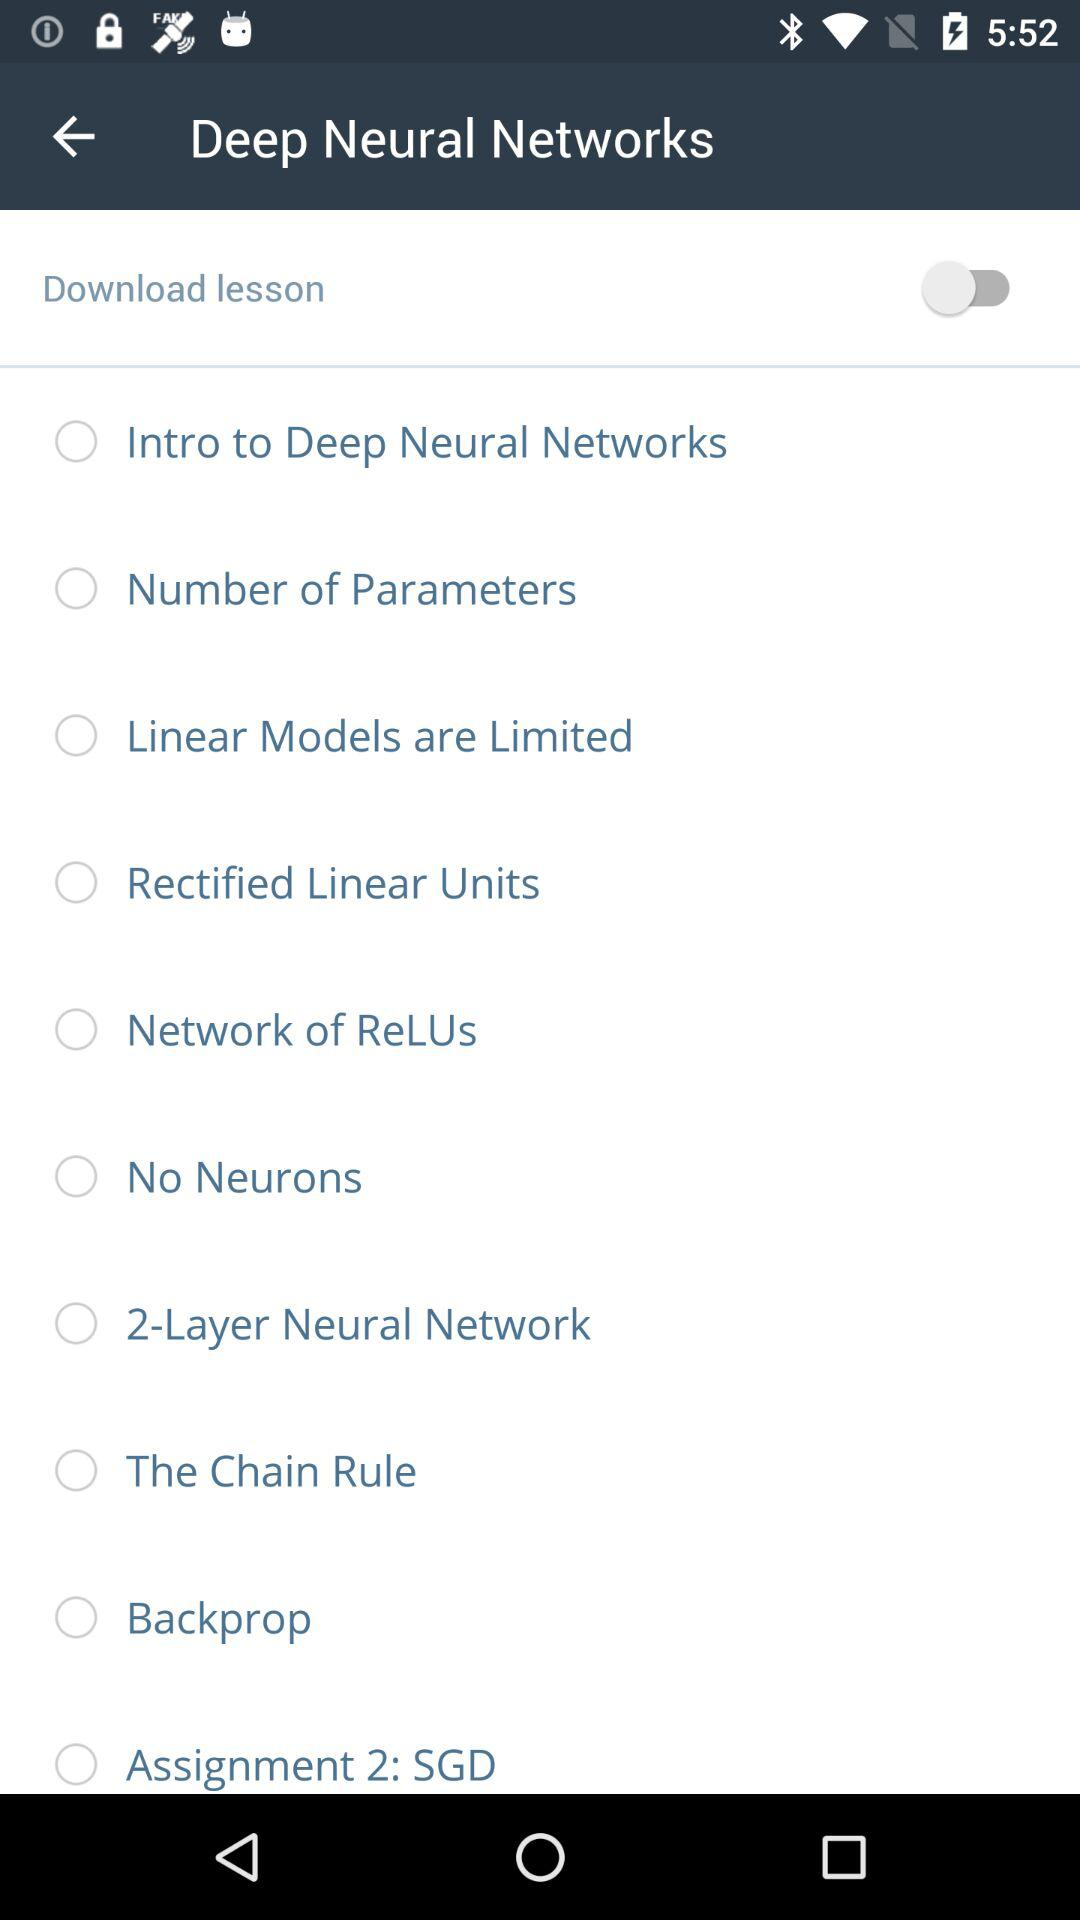What is the status of "Download lesson"? The status is "off". 